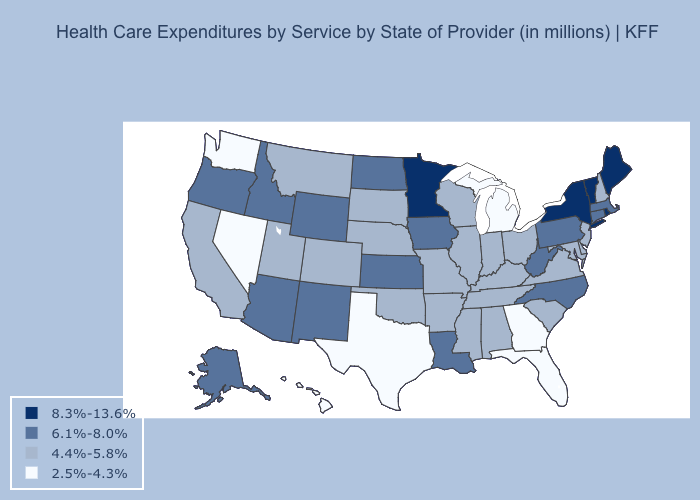Name the states that have a value in the range 8.3%-13.6%?
Answer briefly. Maine, Minnesota, New York, Rhode Island, Vermont. Which states have the highest value in the USA?
Answer briefly. Maine, Minnesota, New York, Rhode Island, Vermont. Name the states that have a value in the range 6.1%-8.0%?
Quick response, please. Alaska, Arizona, Connecticut, Idaho, Iowa, Kansas, Louisiana, Massachusetts, New Mexico, North Carolina, North Dakota, Oregon, Pennsylvania, West Virginia, Wyoming. Is the legend a continuous bar?
Write a very short answer. No. Among the states that border Idaho , which have the lowest value?
Answer briefly. Nevada, Washington. Does Wisconsin have a higher value than Michigan?
Write a very short answer. Yes. Is the legend a continuous bar?
Quick response, please. No. Does Alabama have a lower value than Oregon?
Quick response, please. Yes. Is the legend a continuous bar?
Give a very brief answer. No. Name the states that have a value in the range 6.1%-8.0%?
Concise answer only. Alaska, Arizona, Connecticut, Idaho, Iowa, Kansas, Louisiana, Massachusetts, New Mexico, North Carolina, North Dakota, Oregon, Pennsylvania, West Virginia, Wyoming. Name the states that have a value in the range 6.1%-8.0%?
Be succinct. Alaska, Arizona, Connecticut, Idaho, Iowa, Kansas, Louisiana, Massachusetts, New Mexico, North Carolina, North Dakota, Oregon, Pennsylvania, West Virginia, Wyoming. What is the value of Arizona?
Quick response, please. 6.1%-8.0%. What is the lowest value in states that border Georgia?
Write a very short answer. 2.5%-4.3%. Does California have the highest value in the West?
Be succinct. No. What is the highest value in states that border Illinois?
Concise answer only. 6.1%-8.0%. 